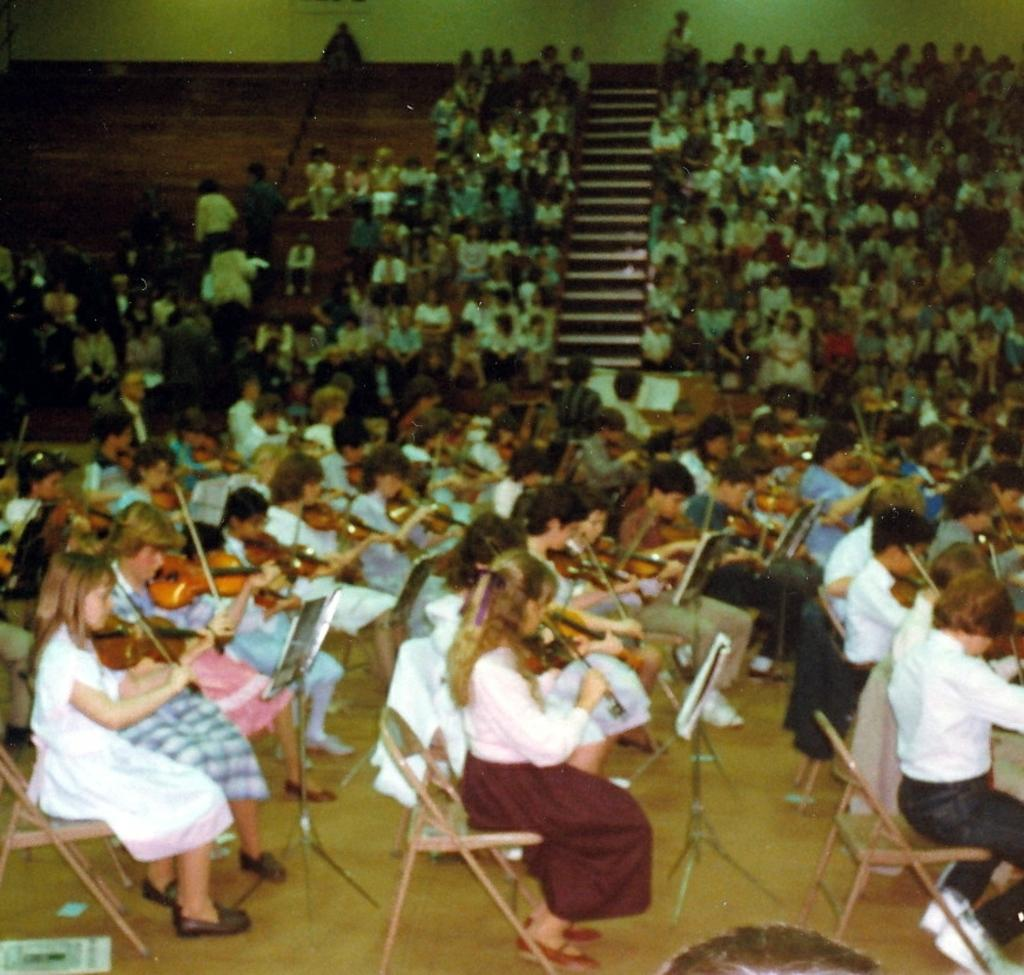What are the people in the image doing? The people in the image are sitting on chairs and playing violins. Who is observing the people playing violins? There is an audience in the image, and they are looking at the people playing violins. What is the position of the audience in relation to the people playing violins? The audience is likely seated in front of the people playing violins, as they are looking at them. What grade is the spoon mentioned in the image? There is no spoon mentioned in the image, so it cannot be assigned a grade. 